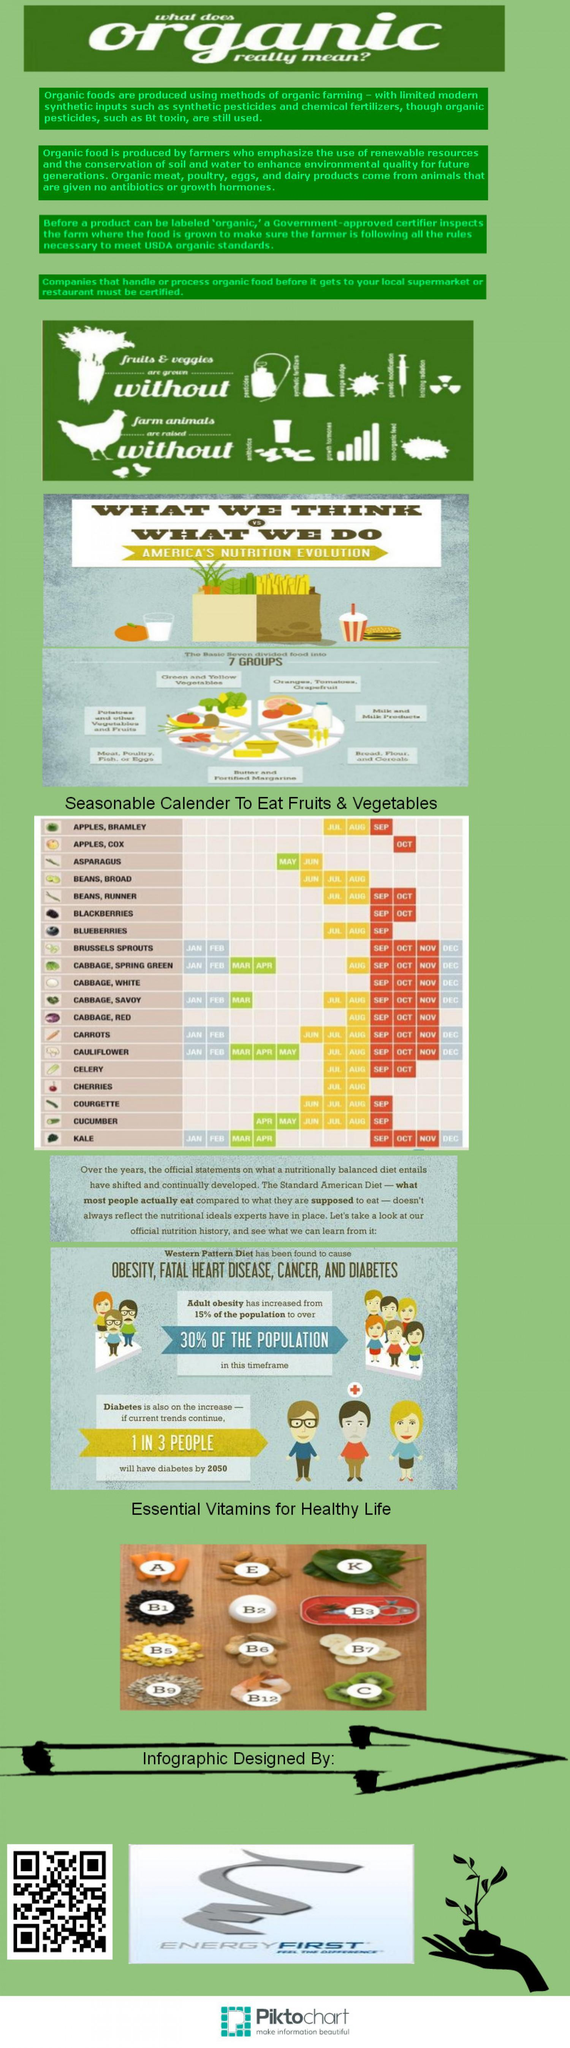Which one is the source of vitamin E-egg or almonds?
Answer the question with a short phrase. almonds Which one is the source of vitamin A-almonds or carrot? carrot What is the number of essential vitamins mentioned in this infographic? 12 How many types of vitamin B are mentioned in this infographic? 8 